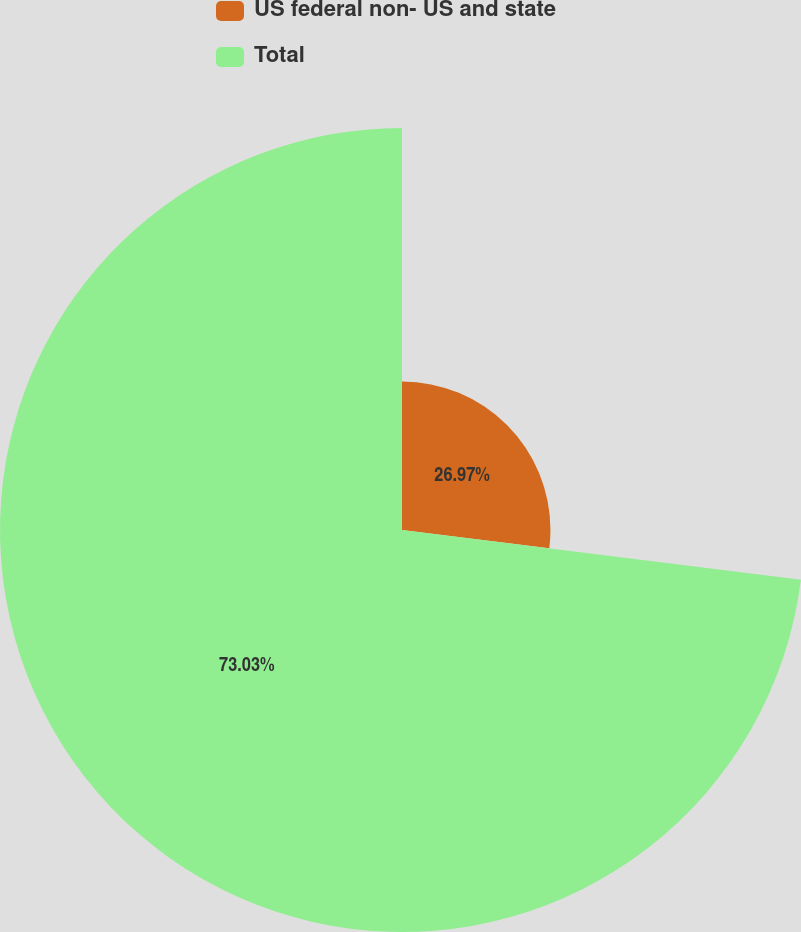Convert chart. <chart><loc_0><loc_0><loc_500><loc_500><pie_chart><fcel>US federal non- US and state<fcel>Total<nl><fcel>26.97%<fcel>73.03%<nl></chart> 